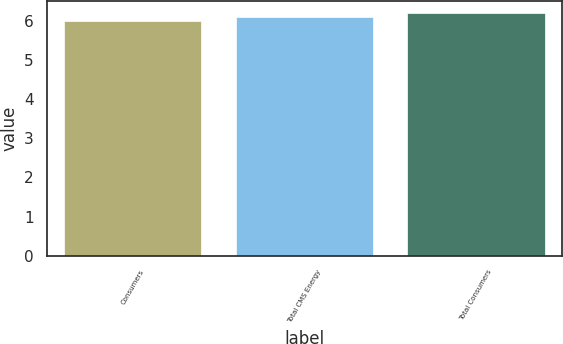Convert chart to OTSL. <chart><loc_0><loc_0><loc_500><loc_500><bar_chart><fcel>Consumers<fcel>Total CMS Energy<fcel>Total Consumers<nl><fcel>6<fcel>6.1<fcel>6.2<nl></chart> 